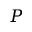<formula> <loc_0><loc_0><loc_500><loc_500>P</formula> 